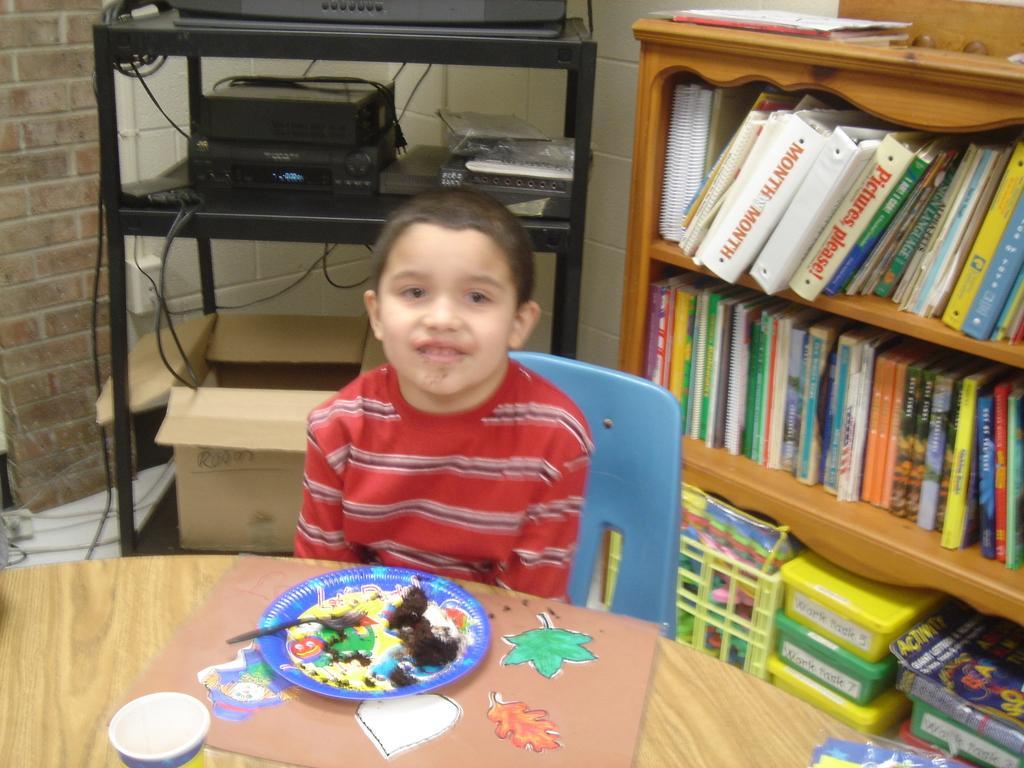Please provide a concise description of this image. This is the picture inside the room. There is a person sitting behind the table. There is a plate, spoon, glass on the table. At the right side of the image there is a cupboard, there are books, boxes inside the cupboard. At the back there is a television and a cardboard box. 